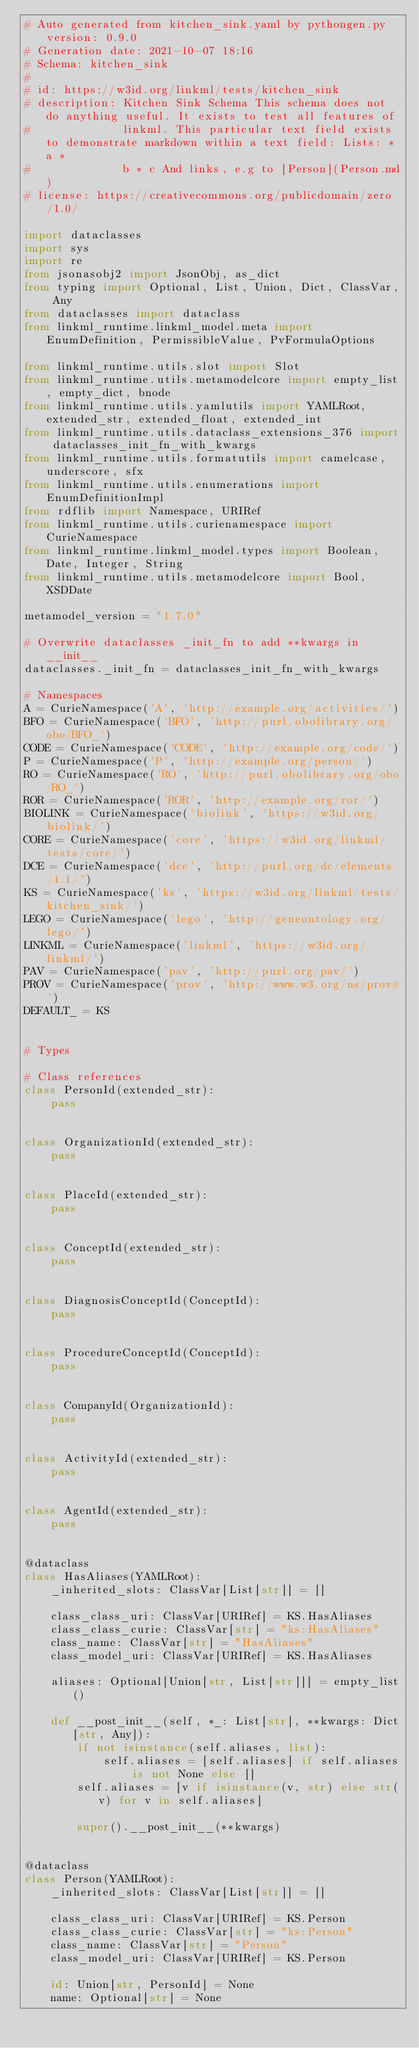<code> <loc_0><loc_0><loc_500><loc_500><_Python_># Auto generated from kitchen_sink.yaml by pythongen.py version: 0.9.0
# Generation date: 2021-10-07 18:16
# Schema: kitchen_sink
#
# id: https://w3id.org/linkml/tests/kitchen_sink
# description: Kitchen Sink Schema This schema does not do anything useful. It exists to test all features of
#              linkml. This particular text field exists to demonstrate markdown within a text field: Lists: * a *
#              b * c And links, e.g to [Person](Person.md)
# license: https://creativecommons.org/publicdomain/zero/1.0/

import dataclasses
import sys
import re
from jsonasobj2 import JsonObj, as_dict
from typing import Optional, List, Union, Dict, ClassVar, Any
from dataclasses import dataclass
from linkml_runtime.linkml_model.meta import EnumDefinition, PermissibleValue, PvFormulaOptions

from linkml_runtime.utils.slot import Slot
from linkml_runtime.utils.metamodelcore import empty_list, empty_dict, bnode
from linkml_runtime.utils.yamlutils import YAMLRoot, extended_str, extended_float, extended_int
from linkml_runtime.utils.dataclass_extensions_376 import dataclasses_init_fn_with_kwargs
from linkml_runtime.utils.formatutils import camelcase, underscore, sfx
from linkml_runtime.utils.enumerations import EnumDefinitionImpl
from rdflib import Namespace, URIRef
from linkml_runtime.utils.curienamespace import CurieNamespace
from linkml_runtime.linkml_model.types import Boolean, Date, Integer, String
from linkml_runtime.utils.metamodelcore import Bool, XSDDate

metamodel_version = "1.7.0"

# Overwrite dataclasses _init_fn to add **kwargs in __init__
dataclasses._init_fn = dataclasses_init_fn_with_kwargs

# Namespaces
A = CurieNamespace('A', 'http://example.org/activities/')
BFO = CurieNamespace('BFO', 'http://purl.obolibrary.org/obo/BFO_')
CODE = CurieNamespace('CODE', 'http://example.org/code/')
P = CurieNamespace('P', 'http://example.org/person/')
RO = CurieNamespace('RO', 'http://purl.obolibrary.org/obo/RO_')
ROR = CurieNamespace('ROR', 'http://example.org/ror/')
BIOLINK = CurieNamespace('biolink', 'https://w3id.org/biolink/')
CORE = CurieNamespace('core', 'https://w3id.org/linkml/tests/core/')
DCE = CurieNamespace('dce', 'http://purl.org/dc/elements/1.1/')
KS = CurieNamespace('ks', 'https://w3id.org/linkml/tests/kitchen_sink/')
LEGO = CurieNamespace('lego', 'http://geneontology.org/lego/')
LINKML = CurieNamespace('linkml', 'https://w3id.org/linkml/')
PAV = CurieNamespace('pav', 'http://purl.org/pav/')
PROV = CurieNamespace('prov', 'http://www.w3.org/ns/prov#')
DEFAULT_ = KS


# Types

# Class references
class PersonId(extended_str):
    pass


class OrganizationId(extended_str):
    pass


class PlaceId(extended_str):
    pass


class ConceptId(extended_str):
    pass


class DiagnosisConceptId(ConceptId):
    pass


class ProcedureConceptId(ConceptId):
    pass


class CompanyId(OrganizationId):
    pass


class ActivityId(extended_str):
    pass


class AgentId(extended_str):
    pass


@dataclass
class HasAliases(YAMLRoot):
    _inherited_slots: ClassVar[List[str]] = []

    class_class_uri: ClassVar[URIRef] = KS.HasAliases
    class_class_curie: ClassVar[str] = "ks:HasAliases"
    class_name: ClassVar[str] = "HasAliases"
    class_model_uri: ClassVar[URIRef] = KS.HasAliases

    aliases: Optional[Union[str, List[str]]] = empty_list()

    def __post_init__(self, *_: List[str], **kwargs: Dict[str, Any]):
        if not isinstance(self.aliases, list):
            self.aliases = [self.aliases] if self.aliases is not None else []
        self.aliases = [v if isinstance(v, str) else str(v) for v in self.aliases]

        super().__post_init__(**kwargs)


@dataclass
class Person(YAMLRoot):
    _inherited_slots: ClassVar[List[str]] = []

    class_class_uri: ClassVar[URIRef] = KS.Person
    class_class_curie: ClassVar[str] = "ks:Person"
    class_name: ClassVar[str] = "Person"
    class_model_uri: ClassVar[URIRef] = KS.Person

    id: Union[str, PersonId] = None
    name: Optional[str] = None</code> 